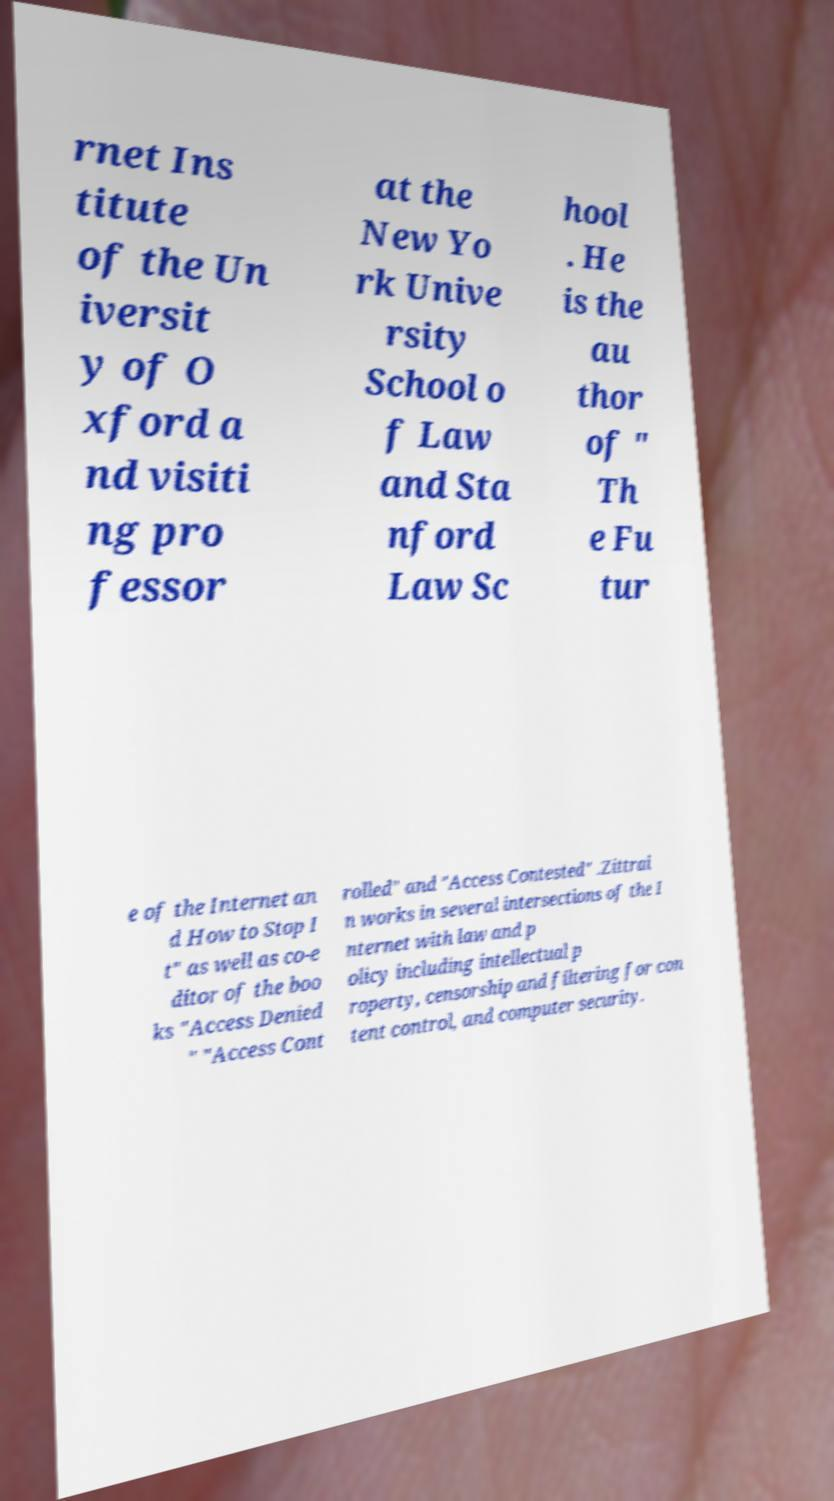Can you accurately transcribe the text from the provided image for me? rnet Ins titute of the Un iversit y of O xford a nd visiti ng pro fessor at the New Yo rk Unive rsity School o f Law and Sta nford Law Sc hool . He is the au thor of " Th e Fu tur e of the Internet an d How to Stop I t" as well as co-e ditor of the boo ks "Access Denied " "Access Cont rolled" and "Access Contested" .Zittrai n works in several intersections of the I nternet with law and p olicy including intellectual p roperty, censorship and filtering for con tent control, and computer security. 